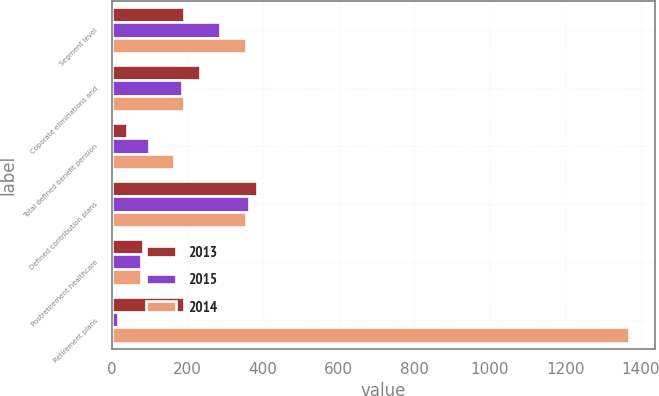<chart> <loc_0><loc_0><loc_500><loc_500><stacked_bar_chart><ecel><fcel>Segment level<fcel>Coporate eliminations and<fcel>Total defined benefit pension<fcel>Defined contribution plans<fcel>Postretirement healthcare<fcel>Retirement plans<nl><fcel>2013<fcel>191<fcel>232<fcel>41<fcel>385<fcel>81<fcel>191<nl><fcel>2015<fcel>285<fcel>186<fcel>99<fcel>363<fcel>78<fcel>15<nl><fcel>2014<fcel>355<fcel>192<fcel>163<fcel>354<fcel>78<fcel>1368<nl></chart> 